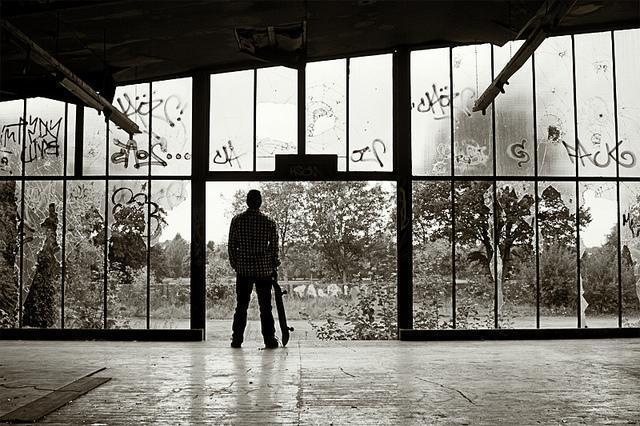How many cars are parked on the street?
Give a very brief answer. 0. 